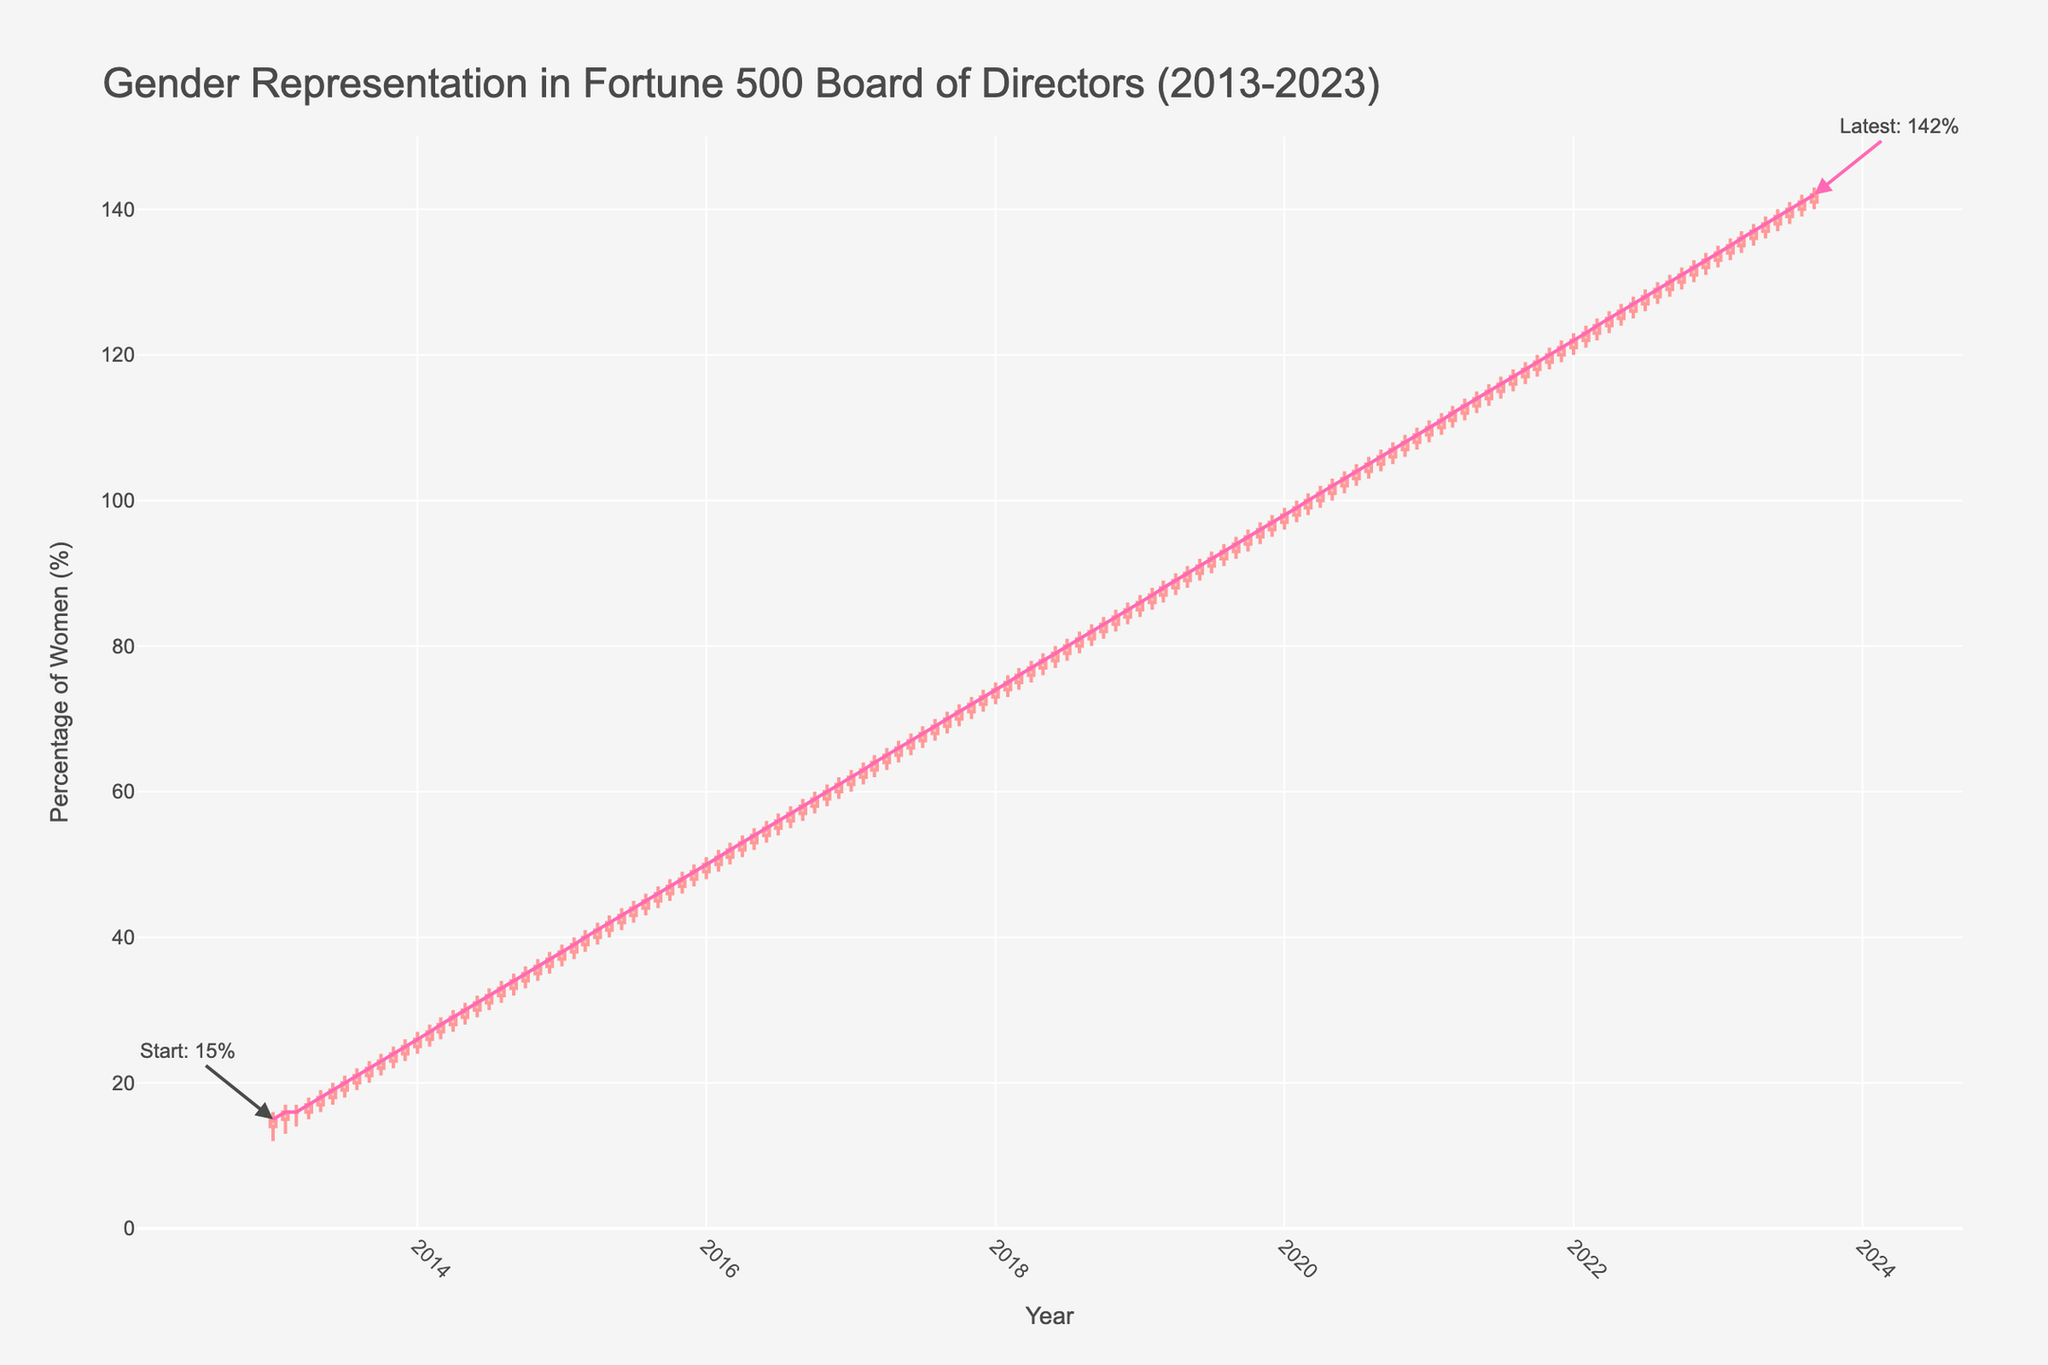What is the title of the figure? The title is located at the top of the figure and provides an overall description of the visualization.
Answer: Gender Representation in Fortune 500 Board of Directors (2013-2023) What is the range of the y-axis in the figure? The y-axis has tick marks that help us determine its range. Observing these ticks from bottom to top provides the range.
Answer: 0 to 150 What is the percentage of women in board positions at the start of the dataset in January 2013? Annotations on the plot label the percentage at the start, providing the exact value for January 2013.
Answer: 15% What was the highest percentage of women representation in October 2015, and how does it compare to October 2016? By locating October 2015 and October 2016 on the x-axis and checking the high values, we can compare the two percentages.
Answer: 48% in 2015; 60% in 2016 How many years of data are depicted in the graph? The x-axis starts at 2013 and ends at 2023. Counting these years provides the total number of years of data available.
Answer: 11 years What is the trend in the percentage of women in board roles from 2013 to 2023? The scatter line added in the plot shows a trend line which helps observe the direction of change from the start year to the end year.
Answer: Increasing What was the lowest percentage of women representation in July 2018, and how does it compare to August 2018? To find the lowest value for each month, we refer to the low values on the candles for July 2018 and August 2018.
Answer: 78% in July; 79% in August Calculate the average percentage increase in women representation from January 2013 to January 2023. First, find the percentage in January 2013 and January 2023. Subtract the earlier value from the later one to get the increase, then divide by the number of years to find the average yearly increase.
Answer: (134 - 15) / 11 ≈ 10.82% Which month had the highest increase in women's representation within a single year, and what were the corresponding percentages? By evaluating the height of the candles in each month over the span of a year, identify which candle has the largest vertical span (height). Compare the high and low values for that candle.
Answer: May 2021; 112% to 114% 